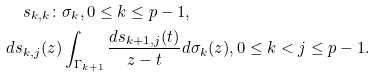Convert formula to latex. <formula><loc_0><loc_0><loc_500><loc_500>s _ { k , k } \colon & \sigma _ { k } , 0 \leq k \leq p - 1 , \\ d s _ { k , j } ( z ) & \int _ { \Gamma _ { k + 1 } } \frac { d s _ { k + 1 , j } ( t ) } { z - t } d \sigma _ { k } ( z ) , 0 \leq k < j \leq p - 1 .</formula> 